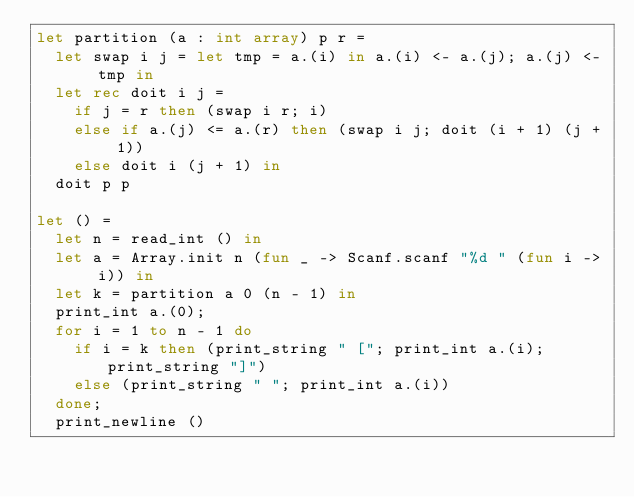Convert code to text. <code><loc_0><loc_0><loc_500><loc_500><_OCaml_>let partition (a : int array) p r =
  let swap i j = let tmp = a.(i) in a.(i) <- a.(j); a.(j) <- tmp in
  let rec doit i j =
    if j = r then (swap i r; i)
    else if a.(j) <= a.(r) then (swap i j; doit (i + 1) (j + 1))
    else doit i (j + 1) in
  doit p p

let () =
  let n = read_int () in
  let a = Array.init n (fun _ -> Scanf.scanf "%d " (fun i -> i)) in
  let k = partition a 0 (n - 1) in
  print_int a.(0);
  for i = 1 to n - 1 do
    if i = k then (print_string " ["; print_int a.(i); print_string "]")
    else (print_string " "; print_int a.(i))
  done;
  print_newline ()</code> 